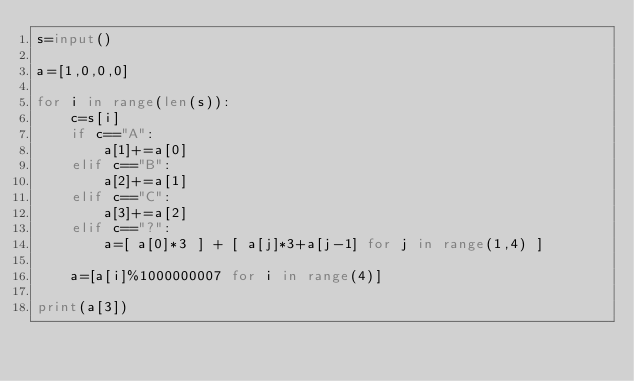<code> <loc_0><loc_0><loc_500><loc_500><_Python_>s=input()

a=[1,0,0,0]

for i in range(len(s)):
    c=s[i]
    if c=="A":
        a[1]+=a[0]
    elif c=="B":
        a[2]+=a[1]
    elif c=="C":
        a[3]+=a[2]
    elif c=="?":
        a=[ a[0]*3 ] + [ a[j]*3+a[j-1] for j in range(1,4) ]

    a=[a[i]%1000000007 for i in range(4)]
    
print(a[3])</code> 